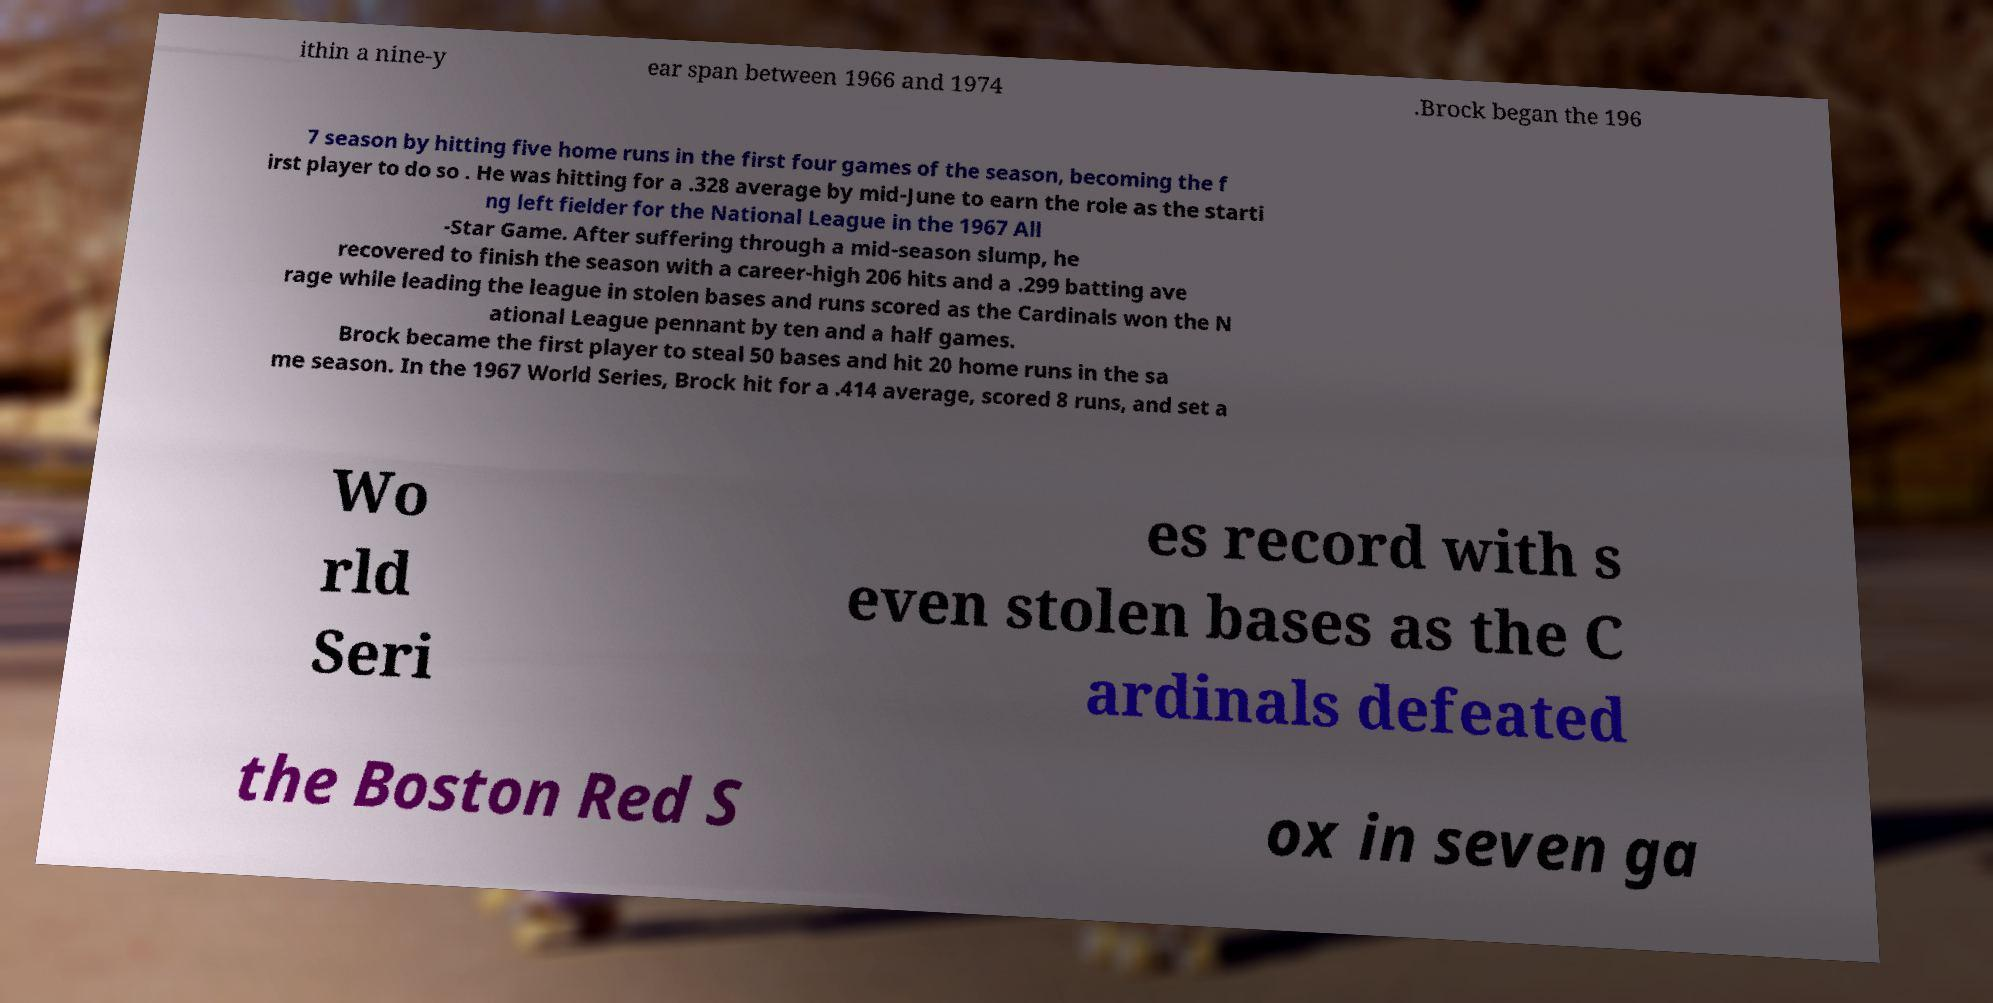Please identify and transcribe the text found in this image. ithin a nine-y ear span between 1966 and 1974 .Brock began the 196 7 season by hitting five home runs in the first four games of the season, becoming the f irst player to do so . He was hitting for a .328 average by mid-June to earn the role as the starti ng left fielder for the National League in the 1967 All -Star Game. After suffering through a mid-season slump, he recovered to finish the season with a career-high 206 hits and a .299 batting ave rage while leading the league in stolen bases and runs scored as the Cardinals won the N ational League pennant by ten and a half games. Brock became the first player to steal 50 bases and hit 20 home runs in the sa me season. In the 1967 World Series, Brock hit for a .414 average, scored 8 runs, and set a Wo rld Seri es record with s even stolen bases as the C ardinals defeated the Boston Red S ox in seven ga 